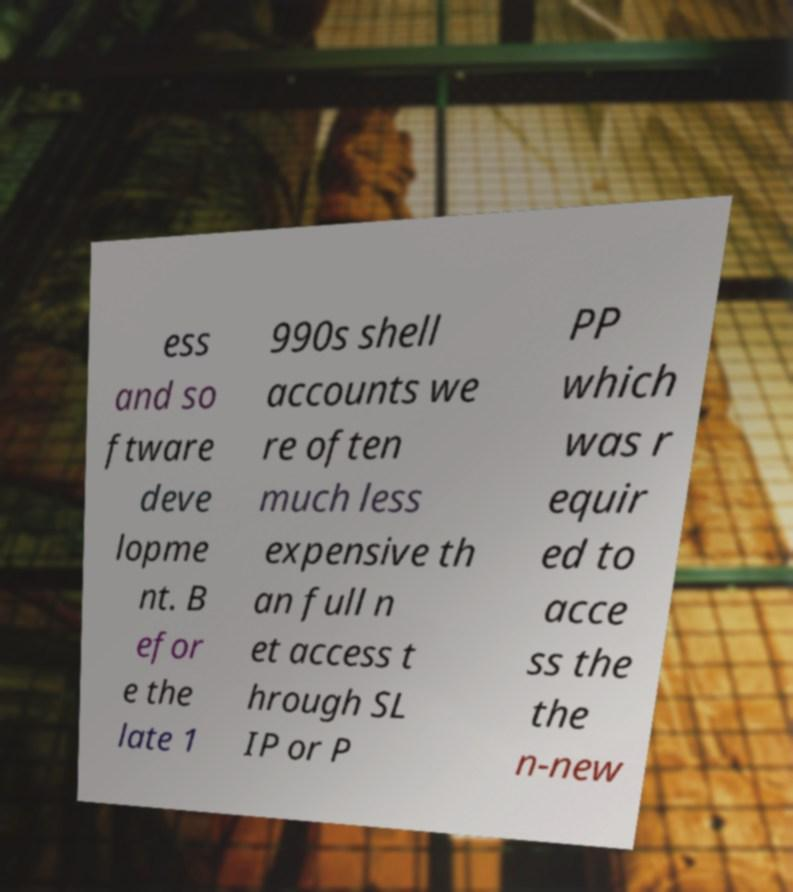Could you extract and type out the text from this image? ess and so ftware deve lopme nt. B efor e the late 1 990s shell accounts we re often much less expensive th an full n et access t hrough SL IP or P PP which was r equir ed to acce ss the the n-new 